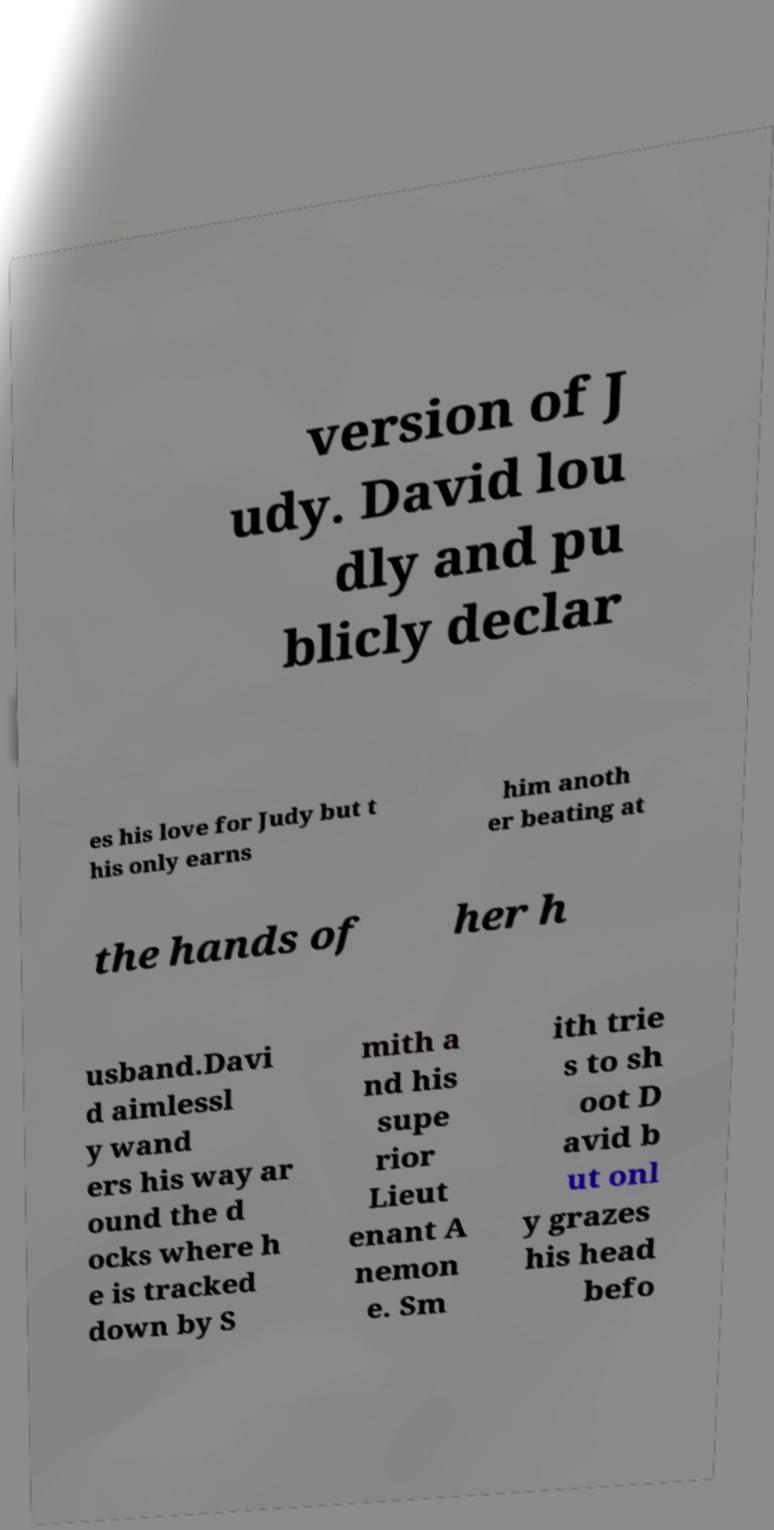There's text embedded in this image that I need extracted. Can you transcribe it verbatim? version of J udy. David lou dly and pu blicly declar es his love for Judy but t his only earns him anoth er beating at the hands of her h usband.Davi d aimlessl y wand ers his way ar ound the d ocks where h e is tracked down by S mith a nd his supe rior Lieut enant A nemon e. Sm ith trie s to sh oot D avid b ut onl y grazes his head befo 